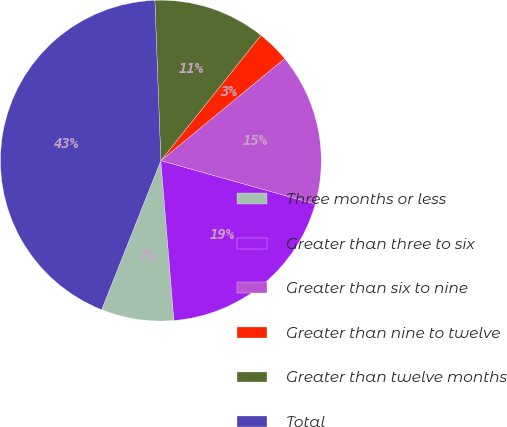Convert chart to OTSL. <chart><loc_0><loc_0><loc_500><loc_500><pie_chart><fcel>Three months or less<fcel>Greater than three to six<fcel>Greater than six to nine<fcel>Greater than nine to twelve<fcel>Greater than twelve months<fcel>Total<nl><fcel>7.31%<fcel>19.34%<fcel>15.33%<fcel>3.3%<fcel>11.32%<fcel>43.39%<nl></chart> 